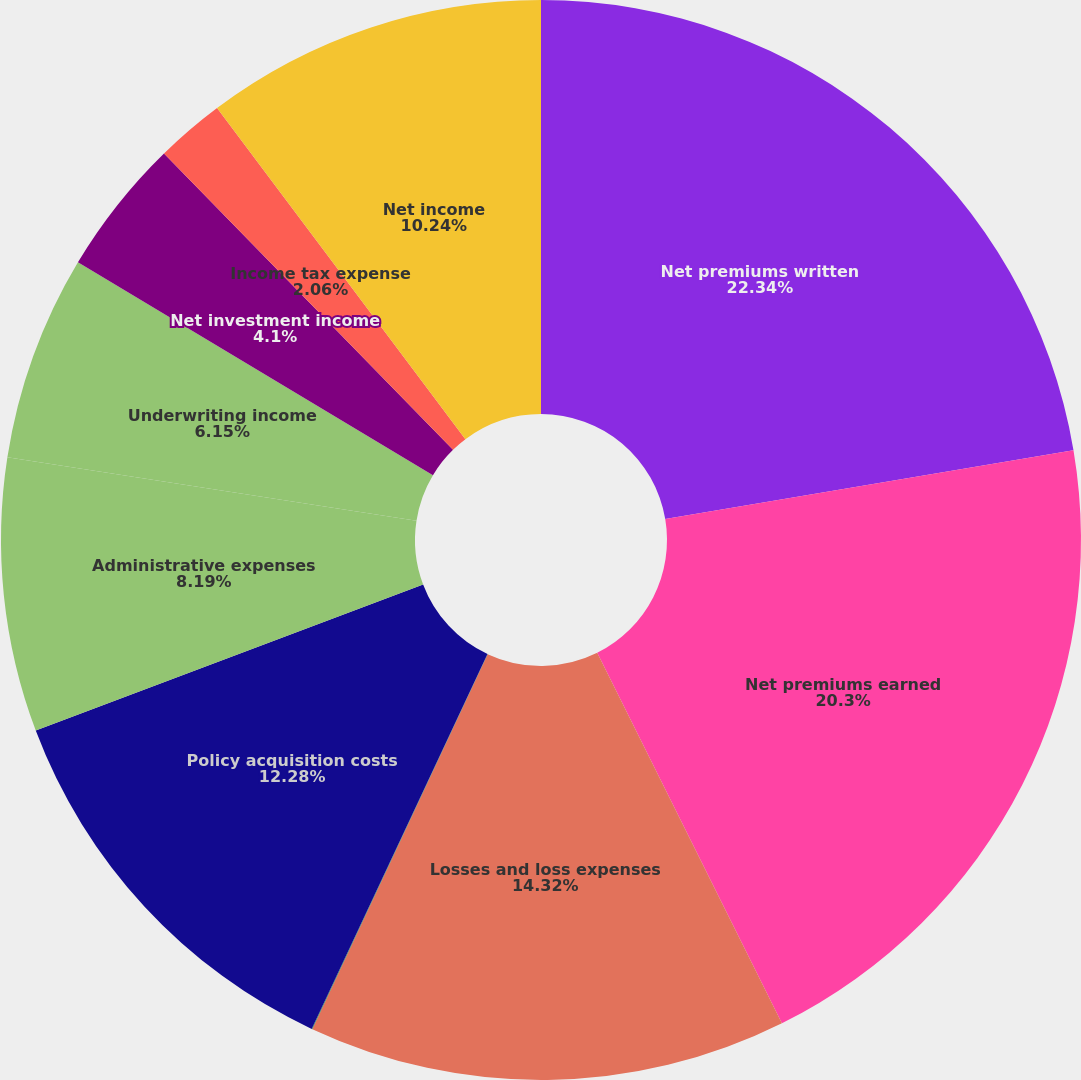Convert chart to OTSL. <chart><loc_0><loc_0><loc_500><loc_500><pie_chart><fcel>Net premiums written<fcel>Net premiums earned<fcel>Losses and loss expenses<fcel>Policy benefits<fcel>Policy acquisition costs<fcel>Administrative expenses<fcel>Underwriting income<fcel>Net investment income<fcel>Income tax expense<fcel>Net income<nl><fcel>22.34%<fcel>20.3%<fcel>14.32%<fcel>0.02%<fcel>12.28%<fcel>8.19%<fcel>6.15%<fcel>4.1%<fcel>2.06%<fcel>10.24%<nl></chart> 